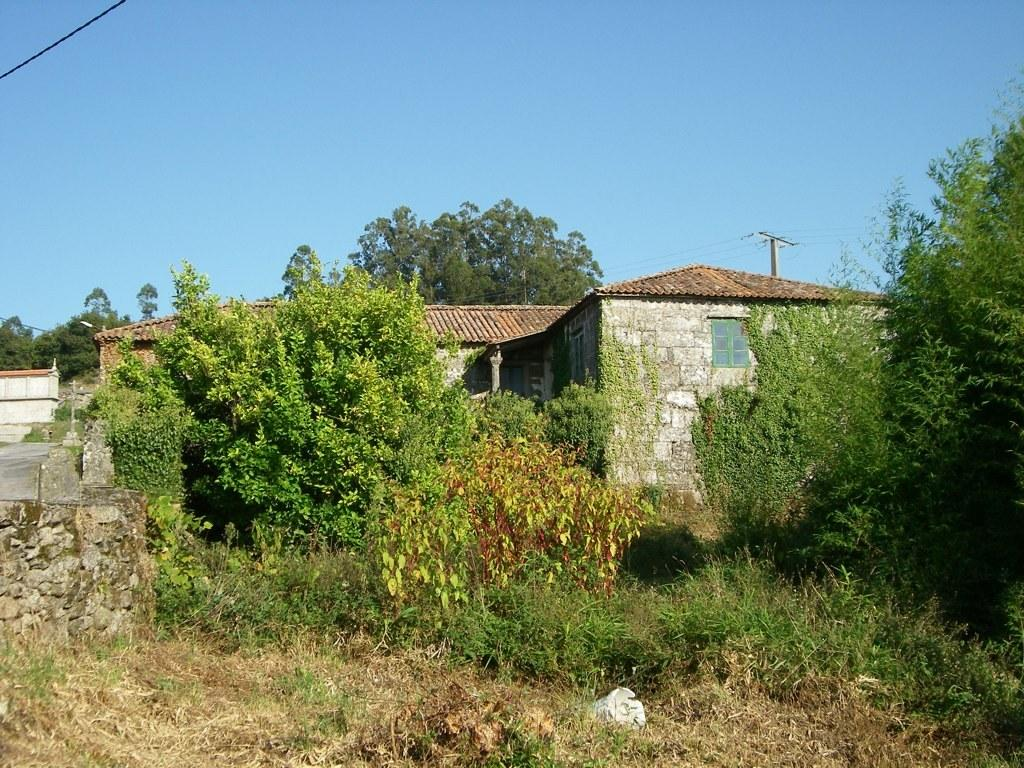What type of vegetation can be seen in the image? There are trees and grass in the image. What type of structures are visible in the image? There are houses and a transmission tower in the image. What is on the right side of the image? There is a brick wall on the right side of the image. What part of the natural environment is visible in the image? The sky is visible in the image. How many angles can be seen in the image? There is no mention of angles in the image, so it is not possible to determine the number of angles present. What type of calculator is being used in the image? There is no calculator present in the image. 